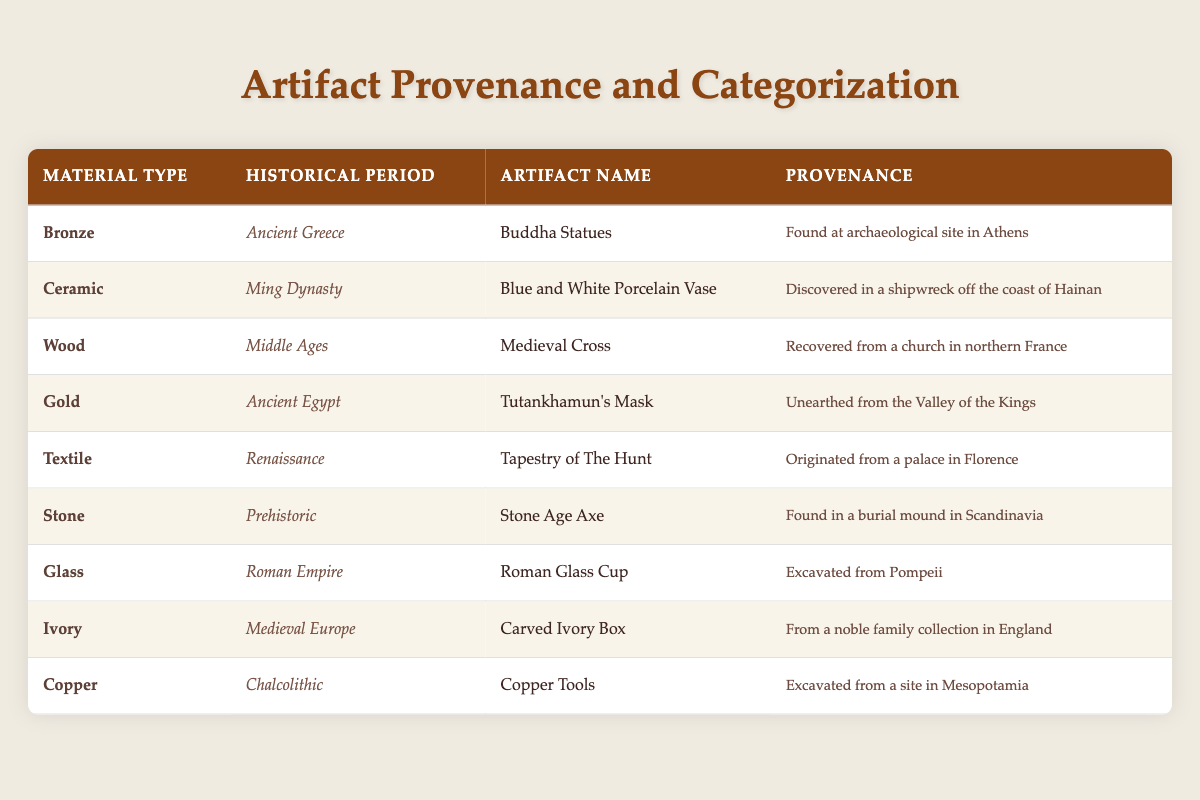What material type is used for the artifact named Tutankhamun's Mask? The table shows that the artifact Tutankhamun's Mask is listed under the material type "Gold."
Answer: Gold How many artifacts from the Medieval historical period are present in the table? There are two artifacts listed under the Medieval historical period: the Medieval Cross made of Wood and the Carved Ivory Box made of Ivory.
Answer: 2 Is there an artifact made of Textile from the Renaissance period? Yes, the table lists the Tapestry of The Hunt as an artifact made of Textile from the Renaissance period, confirming the presence of such an artifact.
Answer: Yes Which historical period does the Roman Glass Cup belong to? The artifact Roman Glass Cup is categorized under the historical period "Roman Empire" as shown in the table.
Answer: Roman Empire What is the provenance of the artifact named Blue and White Porcelain Vase? According to the table, the Blue and White Porcelain Vase was discovered in a shipwreck off the coast of Hainan.
Answer: Discovered in a shipwreck off the coast of Hainan Which material type has artifacts originating from Ancient Greece and Ancient Egypt? The material type that has artifacts from both Ancient Greece (Buddha Statues of Bronze) and Ancient Egypt (Tutankhamun's Mask of Gold) is not the same. They are different materials.
Answer: None What is the total number of artifacts listed from the Prehistoric and ancient periods combined? The Prehistoric period has 1 artifact (Stone Age Axe), and the Ancient period has 2 artifacts (Buddha Statues and Tutankhamun's Mask). Adding them together results in 1 + 2 = 3 artifacts.
Answer: 3 Does the table indicate that there are more artifacts made of Ceramic than those made of Glass? The table shows 1 artifact listed for both Ceramic (Blue and White Porcelain Vase) and Glass (Roman Glass Cup), making the statement false, as they are equal.
Answer: No Which two materials represent the oldest historical periods in the table? The two oldest historical periods listed are Prehistoric (Stone Age Axe made of Stone) and Chalcolithic (Copper Tools made of Copper). They represent the oldest materials and periods in the table.
Answer: Stone, Copper 